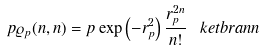Convert formula to latex. <formula><loc_0><loc_0><loc_500><loc_500>p \varrho _ { p } ( n , n ) = p \exp \left ( - r _ { p } ^ { 2 } \right ) \frac { r _ { p } ^ { 2 n } } { n ! } \ k e t b r a { n } { n }</formula> 